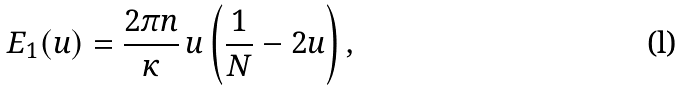Convert formula to latex. <formula><loc_0><loc_0><loc_500><loc_500>E _ { 1 } ( u ) = \frac { 2 \pi n } { \kappa } \, u \left ( \frac { 1 } { N } - 2 u \right ) ,</formula> 